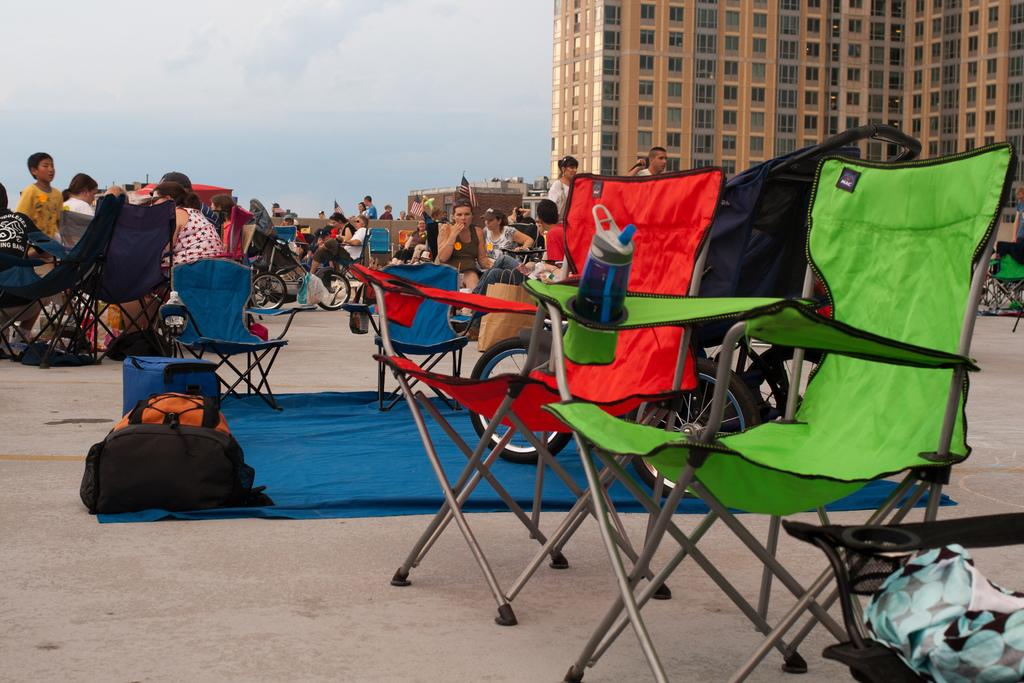What type of chairs are in the foreground of the image? There are red and green chairs in the foreground of the image. What can be seen in the background of the image? There are many people sitting, a bicycle, bags, and a building in the background of the image. Can you tell me how many cords are attached to the bicycle in the image? There is no mention of any cords in the image; the bicycle is not described as having any attached. 